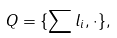Convert formula to latex. <formula><loc_0><loc_0><loc_500><loc_500>Q = \{ \sum l _ { i } , \cdot \} ,</formula> 